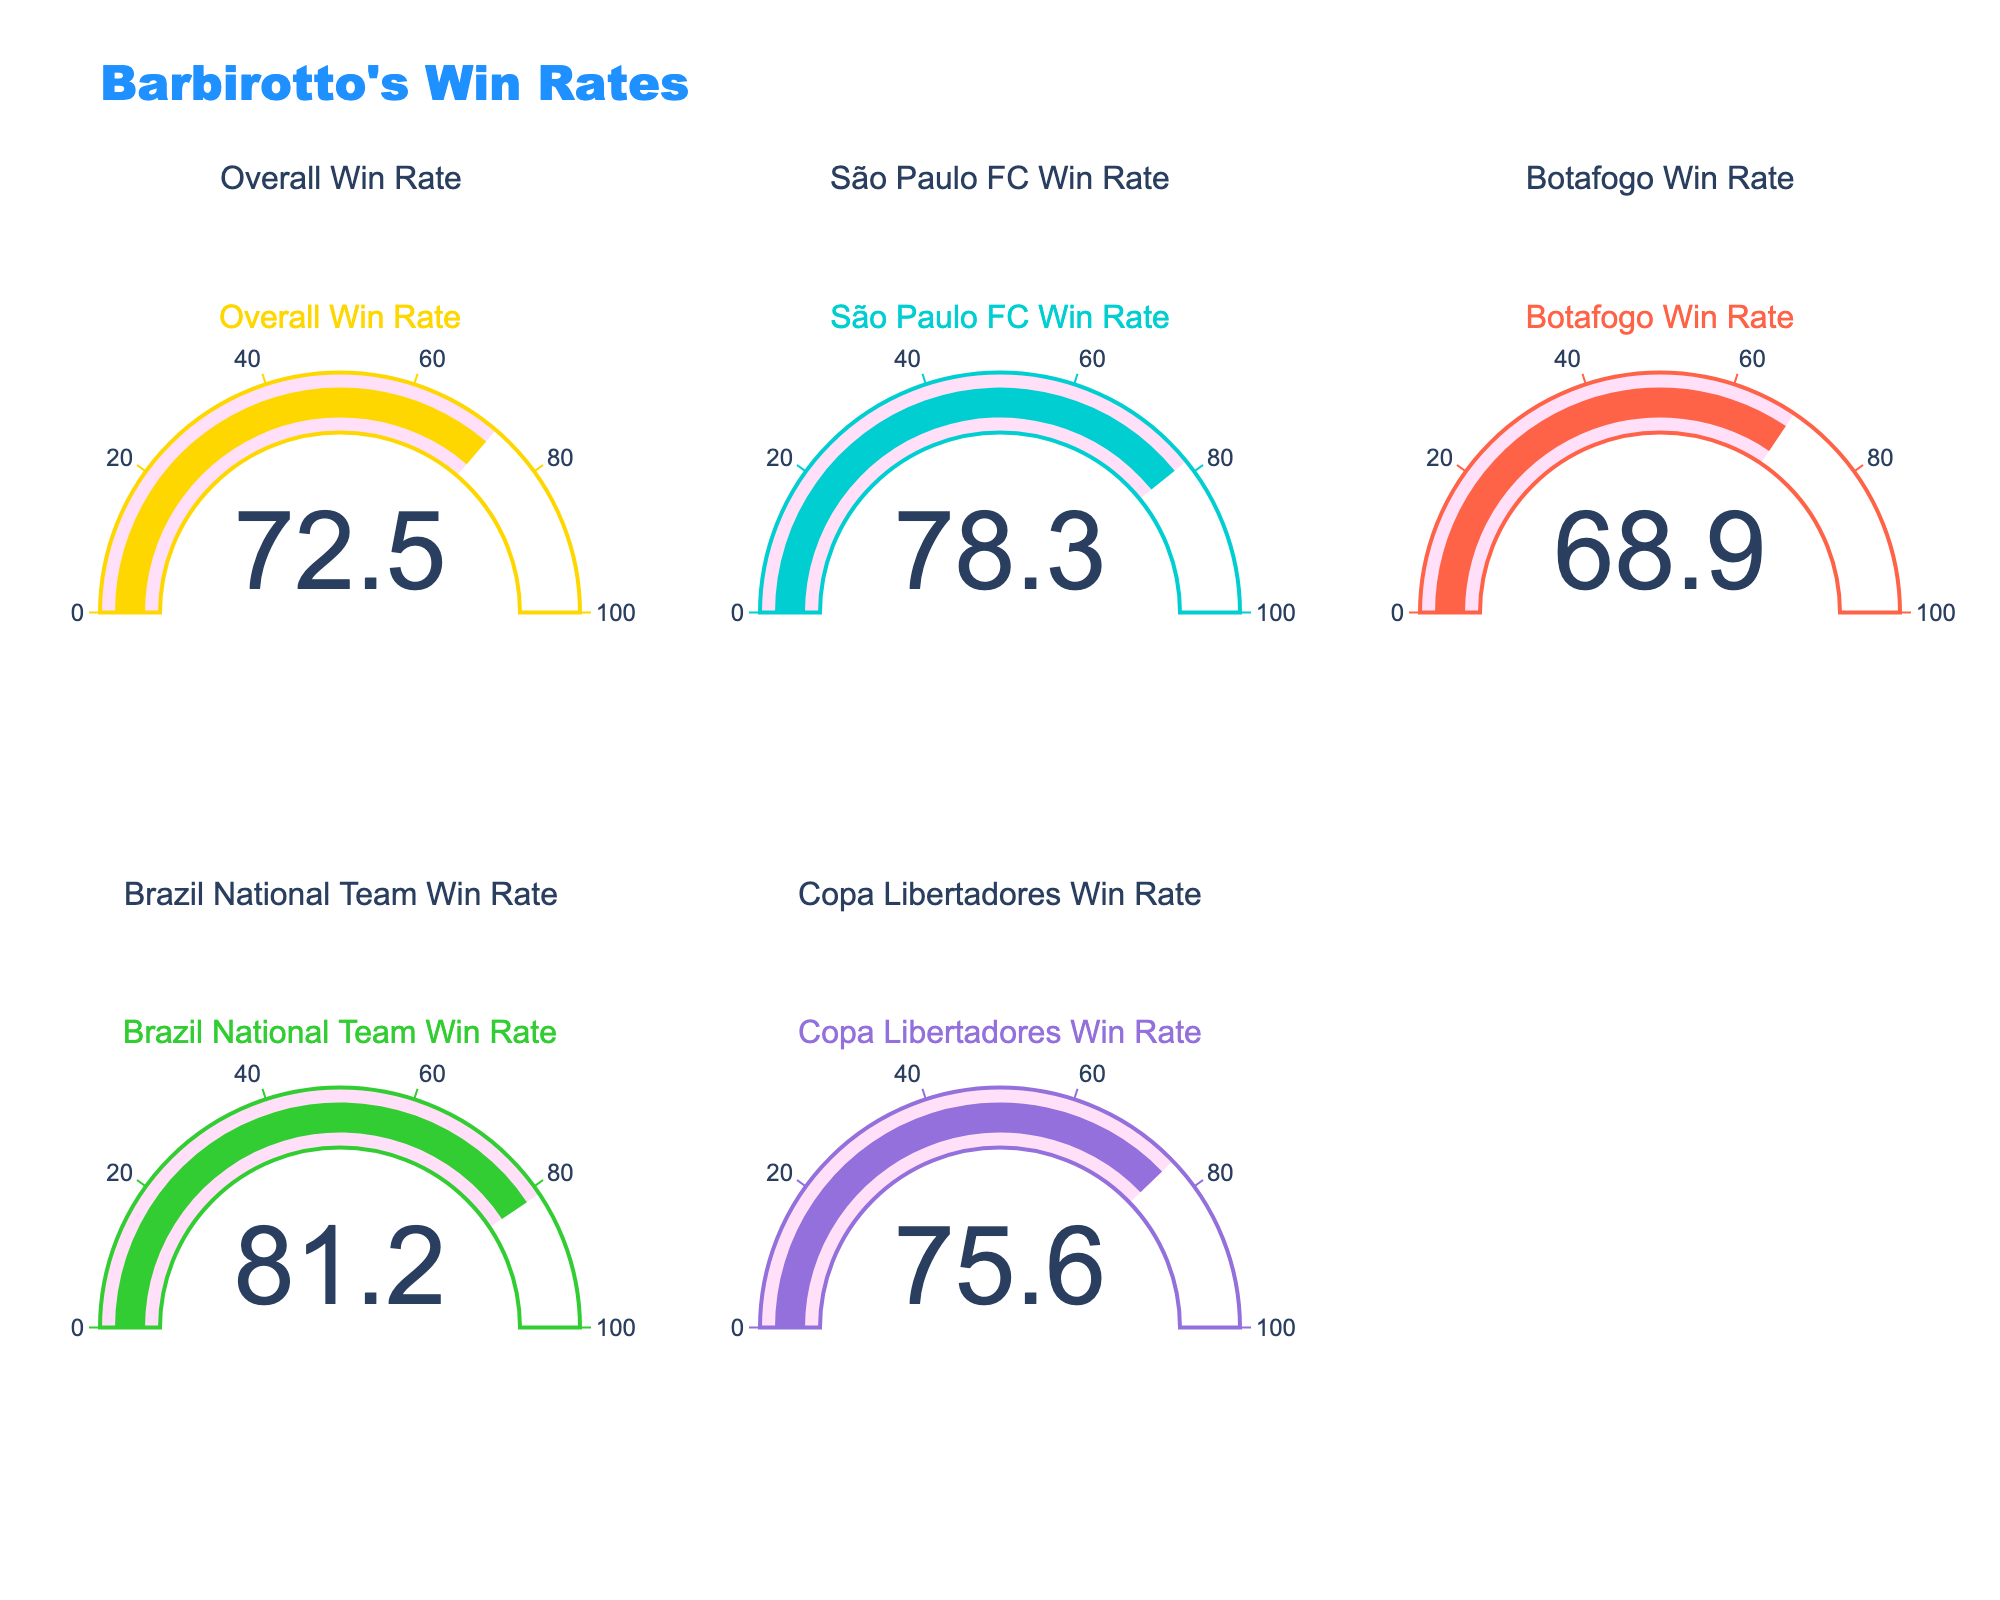What's the title of the plot? The title can be found at the top of the plot.
Answer: Barbirotto's Win Rates What is the overall win rate for Barbirotto? The overall win rate is displayed on the gauge chart labeled "Overall Win Rate."
Answer: 72.5 Which team has the highest win rate for Barbirotto as a goalkeeper? By comparing the win rates on the gauge charts for each team, the highest percentage is found next to Brazil National Team.
Answer: Brazil National Team How much higher is Barbirotto’s win rate with the Brazil National Team compared to Botafogo? Subtract the Botafogo win rate from the Brazil National Team win rate: 81.2 - 68.9 = 12.3.
Answer: 12.3 What is the win rate for Barbirotto when playing for São Paulo FC? The São Paulo FC win rate is displayed on the gauge chart labeled "São Paulo FC Win Rate."
Answer: 78.3 Arrange the teams by Barbirotto's win rate in ascending order. Reading the win rates from the gauge charts: Botafogo (68.9), Overall (72.5), Copa Libertadores (75.6), São Paulo FC (78.3), Brazil National Team (81.2).
Answer: Botafogo, Overall, Copa Libertadores, São Paulo FC, Brazil National Team What is the average win rate across all competitions displayed? Sum up all the win rates and divide by the number of competitions: (72.5 + 78.3 + 68.9 + 81.2 + 75.6) / 5 = 75.3.
Answer: 75.3 Which competitions have a win rate above 75%? Check each gauge chart: Overall (72.5), São Paulo FC (78.3), Botafogo (68.9), Brazil National Team (81.2), Copa Libertadores (75.6). The ones above 75% are São Paulo FC, Brazil National Team, and Copa Libertadores.
Answer: São Paulo FC, Brazil National Team, Copa Libertadores What's the difference between Barbirotto's win rate for São Paulo FC and Copa Libertadores? Subtract the Copa Libertadores win rate from the São Paulo FC win rate: 78.3 - 75.6 = 2.7.
Answer: 2.7 Which win rate is closest to 70%? Check the values: Overall (72.5), São Paulo FC (78.3), Botafogo (68.9), Brazil National Team (81.2), Copa Libertadores (75.6). The closest to 70% is Botafogo at 68.9%.
Answer: Botafogo 